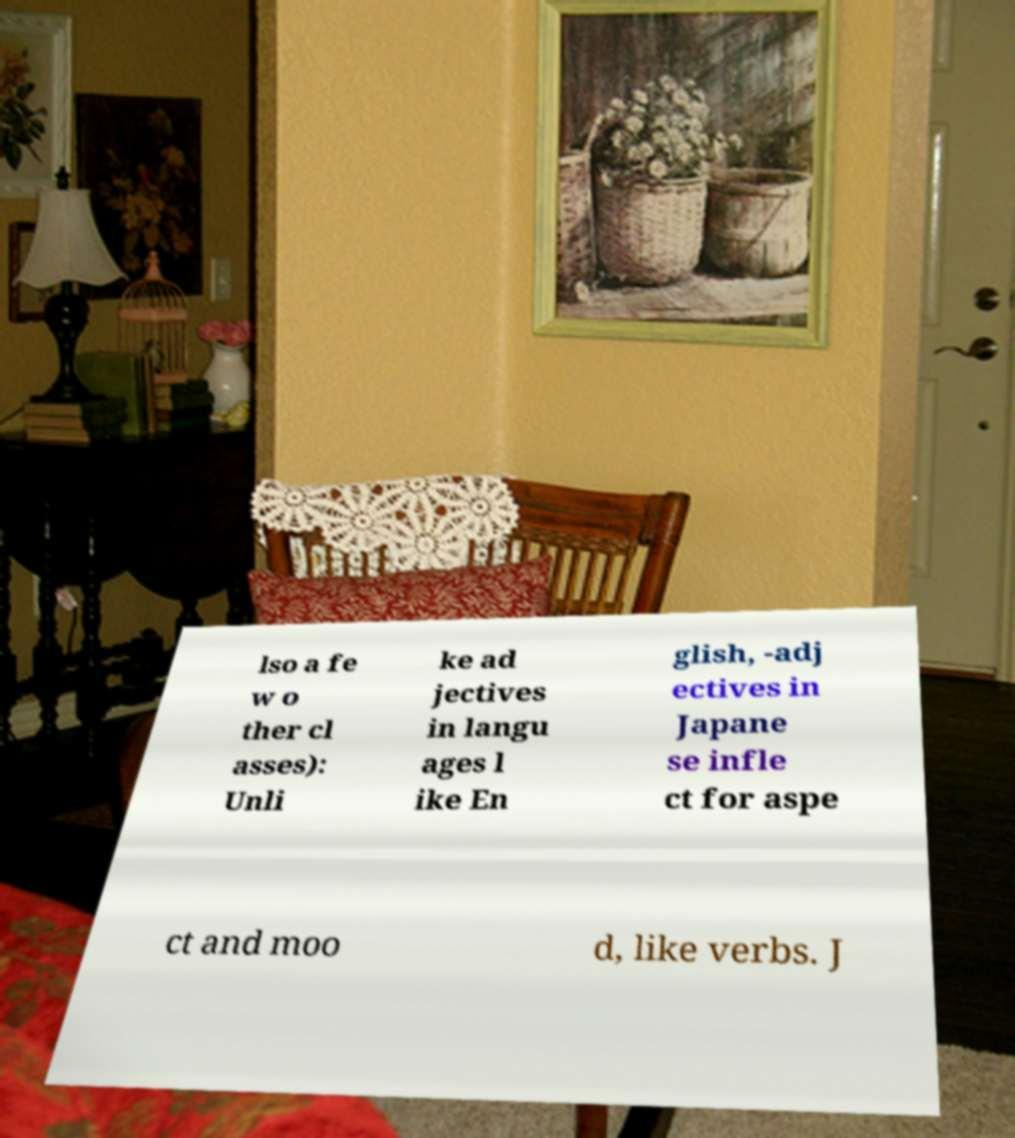Could you assist in decoding the text presented in this image and type it out clearly? lso a fe w o ther cl asses): Unli ke ad jectives in langu ages l ike En glish, -adj ectives in Japane se infle ct for aspe ct and moo d, like verbs. J 